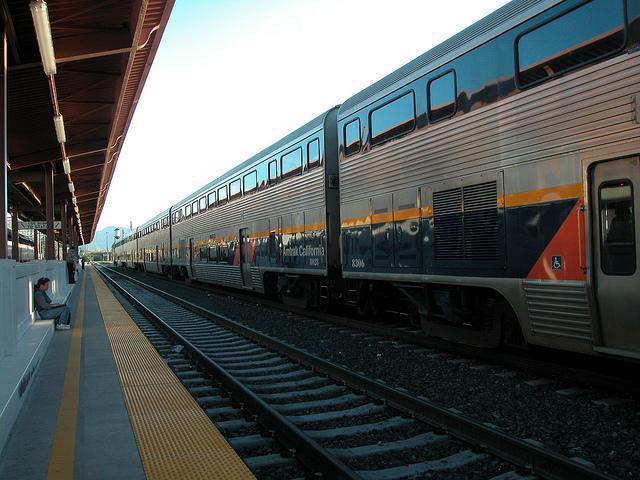How many sets of train tracks are there?
Give a very brief answer. 2. How many giraffes are inside the building?
Give a very brief answer. 0. 